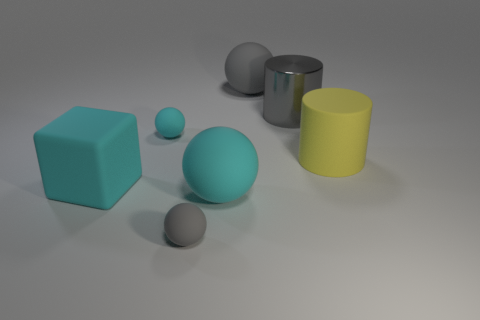Subtract all large gray balls. How many balls are left? 3 Subtract all brown cylinders. How many gray balls are left? 2 Add 1 rubber spheres. How many objects exist? 8 Subtract all cyan balls. How many balls are left? 2 Subtract all cylinders. How many objects are left? 5 Subtract 1 spheres. How many spheres are left? 3 Add 6 large gray matte spheres. How many large gray matte spheres exist? 7 Subtract 0 purple balls. How many objects are left? 7 Subtract all yellow cylinders. Subtract all gray cubes. How many cylinders are left? 1 Subtract all purple metal cylinders. Subtract all balls. How many objects are left? 3 